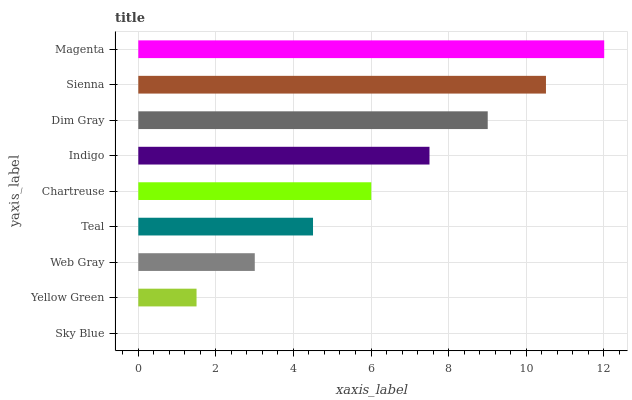Is Sky Blue the minimum?
Answer yes or no. Yes. Is Magenta the maximum?
Answer yes or no. Yes. Is Yellow Green the minimum?
Answer yes or no. No. Is Yellow Green the maximum?
Answer yes or no. No. Is Yellow Green greater than Sky Blue?
Answer yes or no. Yes. Is Sky Blue less than Yellow Green?
Answer yes or no. Yes. Is Sky Blue greater than Yellow Green?
Answer yes or no. No. Is Yellow Green less than Sky Blue?
Answer yes or no. No. Is Chartreuse the high median?
Answer yes or no. Yes. Is Chartreuse the low median?
Answer yes or no. Yes. Is Yellow Green the high median?
Answer yes or no. No. Is Sienna the low median?
Answer yes or no. No. 